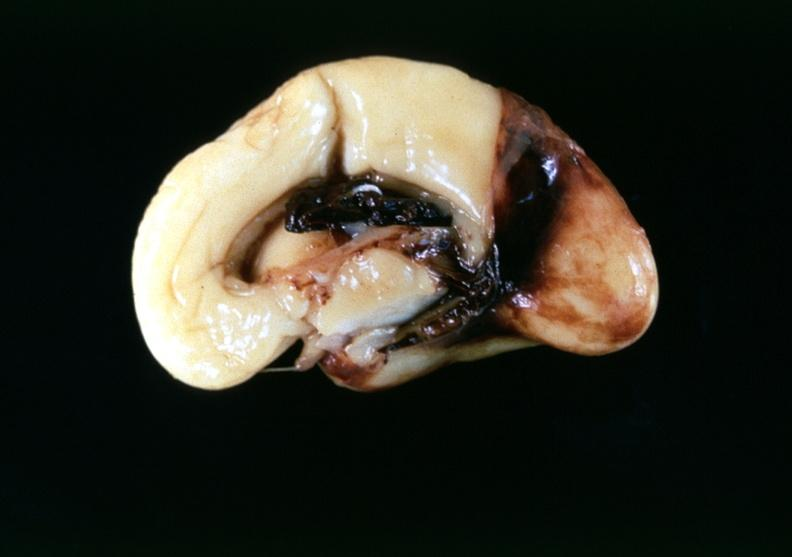s nervous present?
Answer the question using a single word or phrase. Yes 